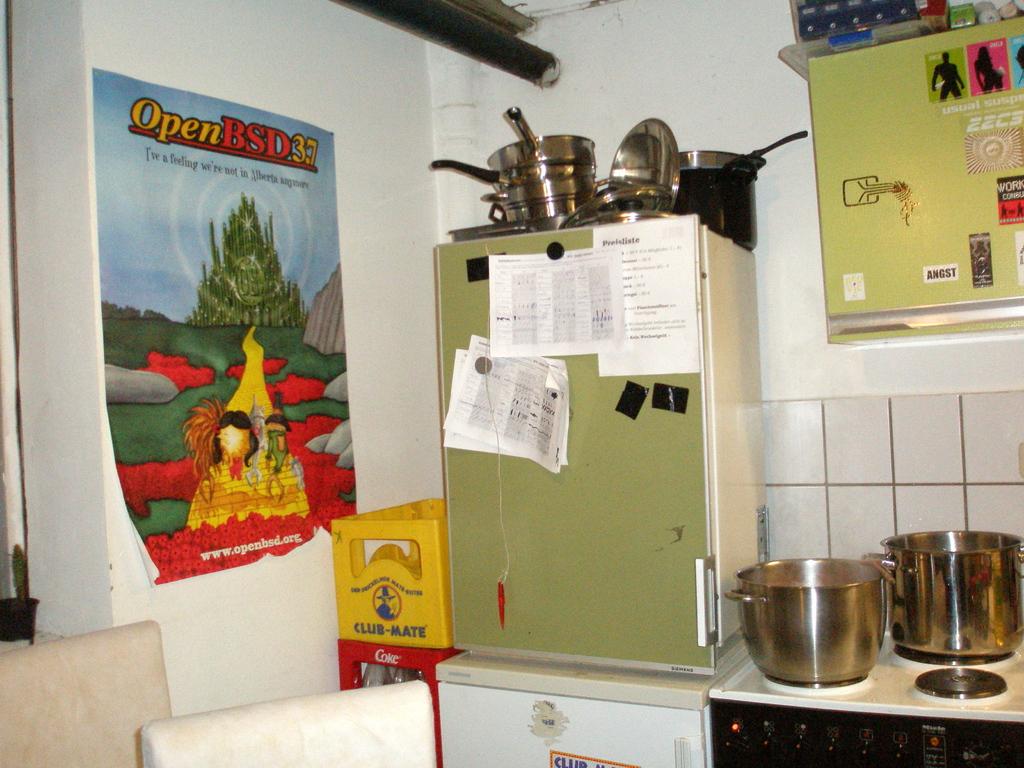What does the yellow crate that is next to the green fridge say?
Provide a short and direct response. Club-mate. What does it say on the poster?
Your answer should be compact. Openbsd37. 